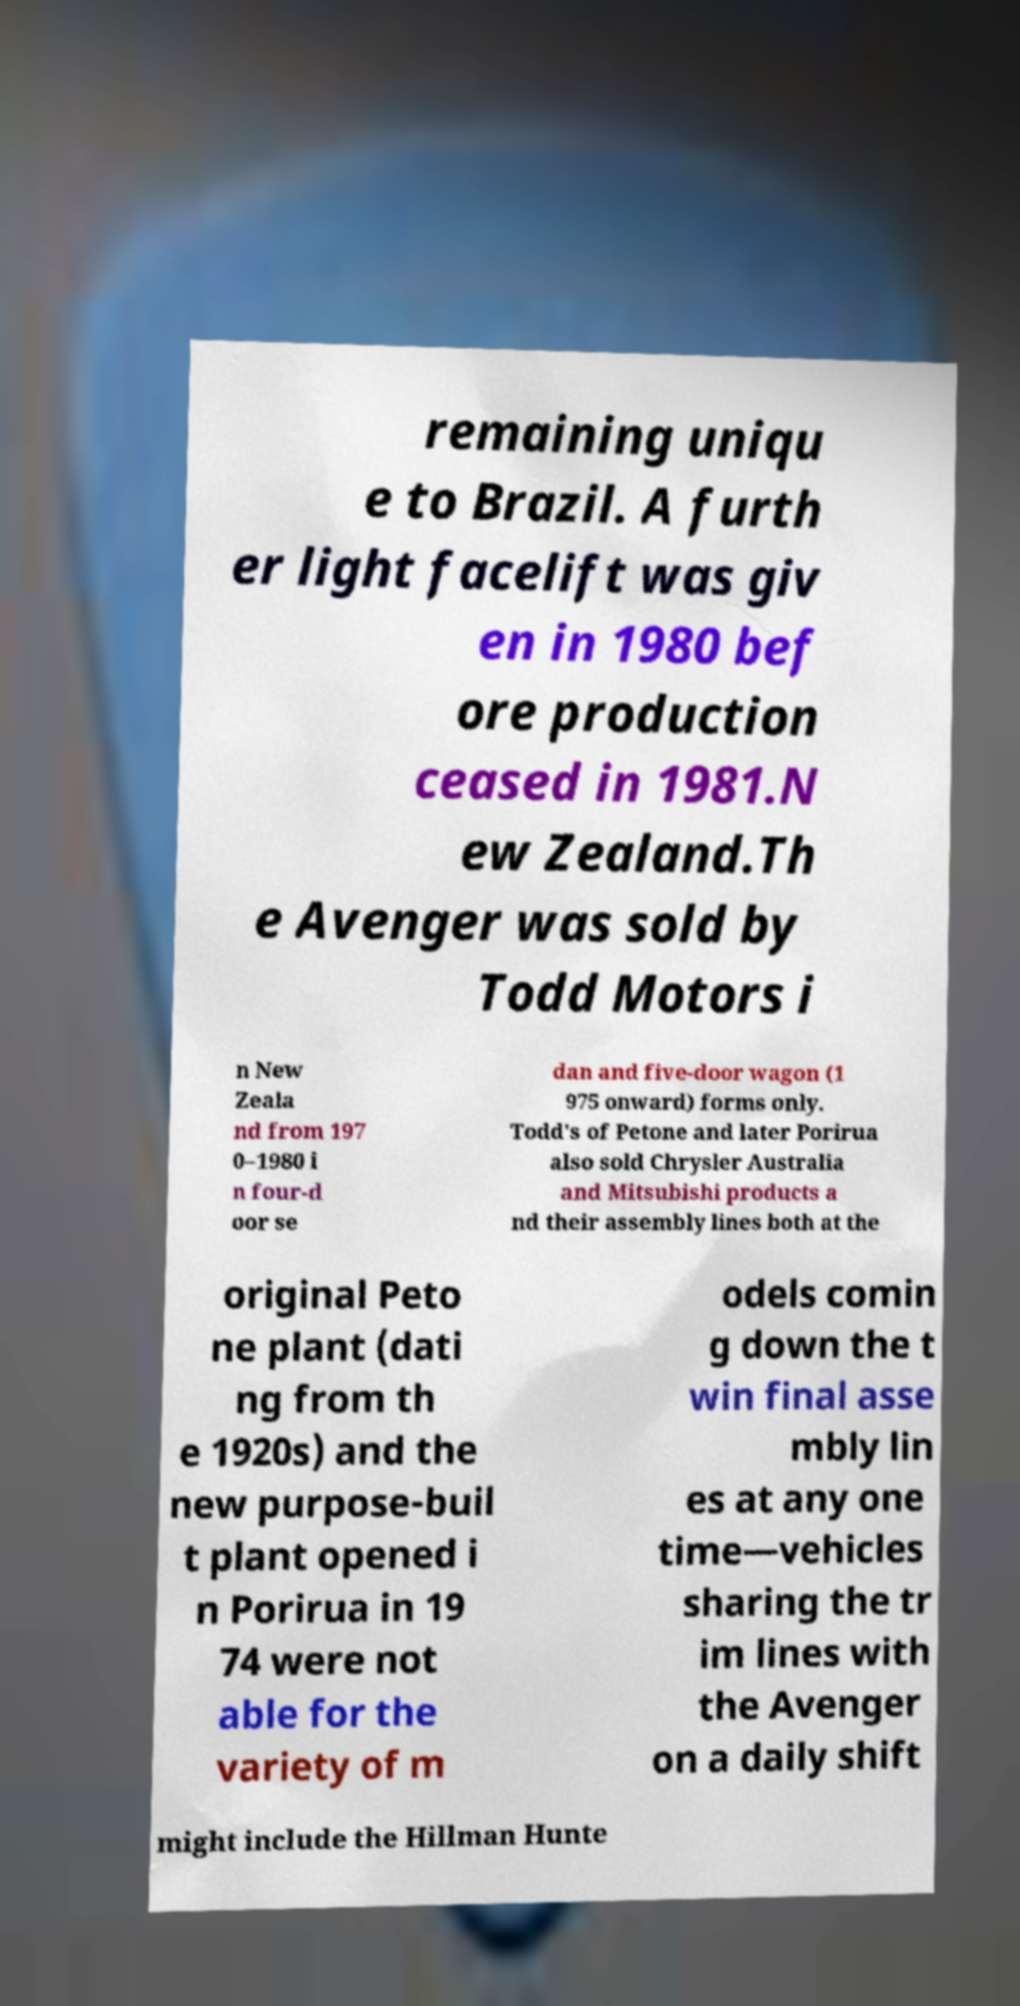I need the written content from this picture converted into text. Can you do that? remaining uniqu e to Brazil. A furth er light facelift was giv en in 1980 bef ore production ceased in 1981.N ew Zealand.Th e Avenger was sold by Todd Motors i n New Zeala nd from 197 0–1980 i n four-d oor se dan and five-door wagon (1 975 onward) forms only. Todd's of Petone and later Porirua also sold Chrysler Australia and Mitsubishi products a nd their assembly lines both at the original Peto ne plant (dati ng from th e 1920s) and the new purpose-buil t plant opened i n Porirua in 19 74 were not able for the variety of m odels comin g down the t win final asse mbly lin es at any one time—vehicles sharing the tr im lines with the Avenger on a daily shift might include the Hillman Hunte 